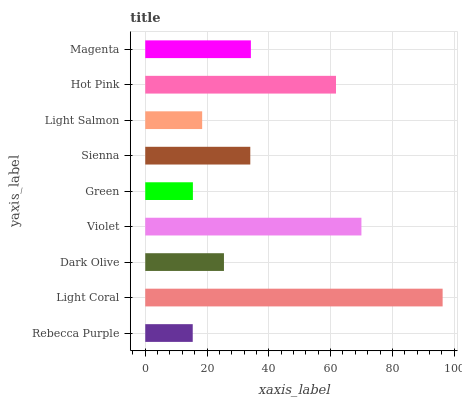Is Rebecca Purple the minimum?
Answer yes or no. Yes. Is Light Coral the maximum?
Answer yes or no. Yes. Is Dark Olive the minimum?
Answer yes or no. No. Is Dark Olive the maximum?
Answer yes or no. No. Is Light Coral greater than Dark Olive?
Answer yes or no. Yes. Is Dark Olive less than Light Coral?
Answer yes or no. Yes. Is Dark Olive greater than Light Coral?
Answer yes or no. No. Is Light Coral less than Dark Olive?
Answer yes or no. No. Is Sienna the high median?
Answer yes or no. Yes. Is Sienna the low median?
Answer yes or no. Yes. Is Dark Olive the high median?
Answer yes or no. No. Is Light Coral the low median?
Answer yes or no. No. 